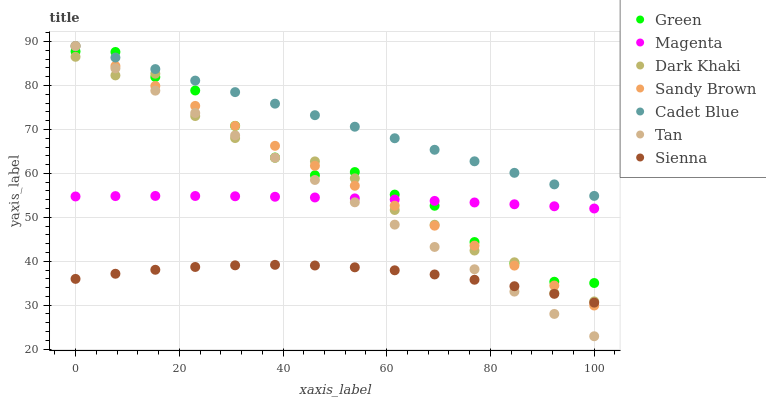Does Sienna have the minimum area under the curve?
Answer yes or no. Yes. Does Cadet Blue have the maximum area under the curve?
Answer yes or no. Yes. Does Dark Khaki have the minimum area under the curve?
Answer yes or no. No. Does Dark Khaki have the maximum area under the curve?
Answer yes or no. No. Is Tan the smoothest?
Answer yes or no. Yes. Is Dark Khaki the roughest?
Answer yes or no. Yes. Is Cadet Blue the smoothest?
Answer yes or no. No. Is Cadet Blue the roughest?
Answer yes or no. No. Does Tan have the lowest value?
Answer yes or no. Yes. Does Dark Khaki have the lowest value?
Answer yes or no. No. Does Tan have the highest value?
Answer yes or no. Yes. Does Dark Khaki have the highest value?
Answer yes or no. No. Is Dark Khaki less than Cadet Blue?
Answer yes or no. Yes. Is Cadet Blue greater than Dark Khaki?
Answer yes or no. Yes. Does Sandy Brown intersect Dark Khaki?
Answer yes or no. Yes. Is Sandy Brown less than Dark Khaki?
Answer yes or no. No. Is Sandy Brown greater than Dark Khaki?
Answer yes or no. No. Does Dark Khaki intersect Cadet Blue?
Answer yes or no. No. 